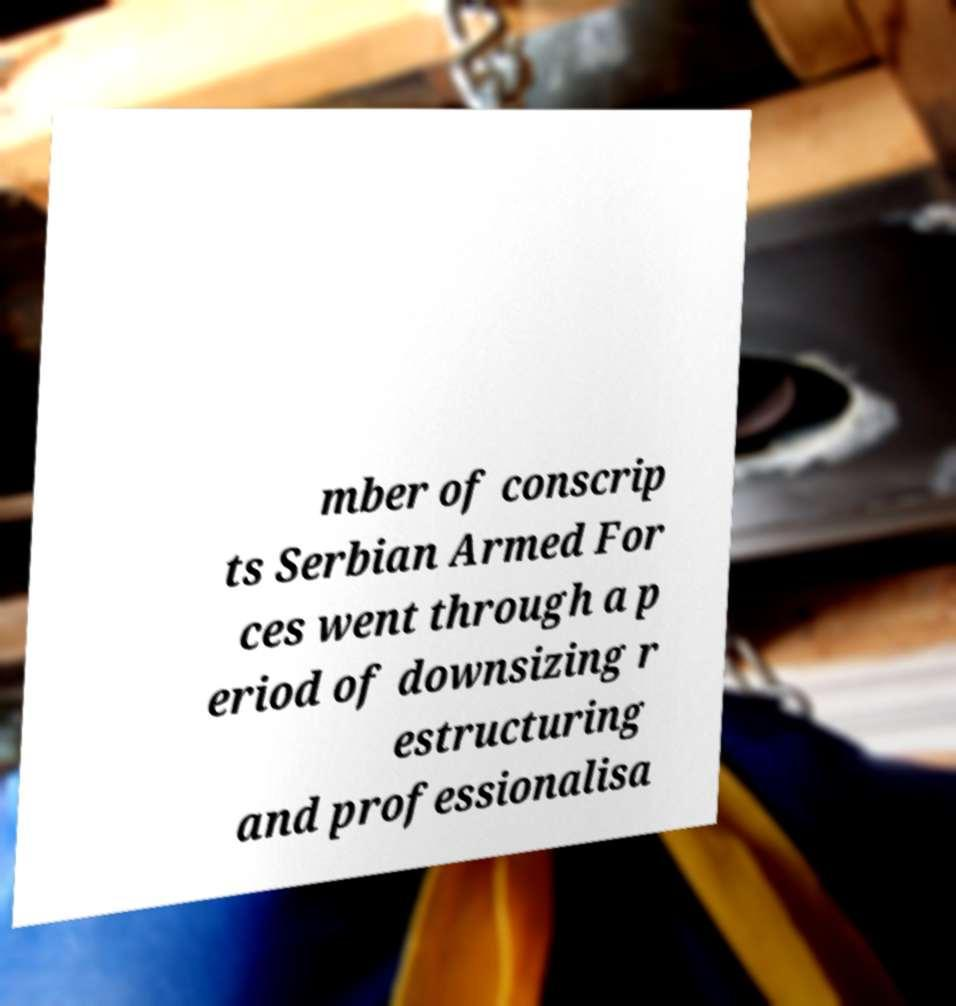Please read and relay the text visible in this image. What does it say? mber of conscrip ts Serbian Armed For ces went through a p eriod of downsizing r estructuring and professionalisa 